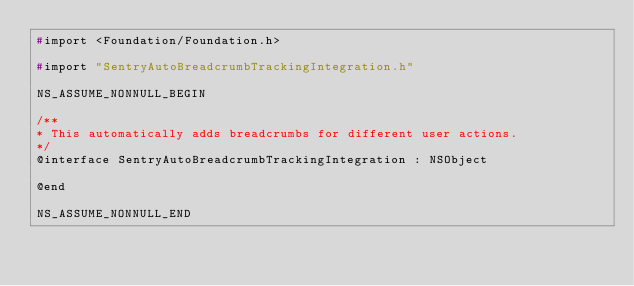<code> <loc_0><loc_0><loc_500><loc_500><_C_>#import <Foundation/Foundation.h>

#import "SentryAutoBreadcrumbTrackingIntegration.h"

NS_ASSUME_NONNULL_BEGIN

/**
* This automatically adds breadcrumbs for different user actions.
*/
@interface SentryAutoBreadcrumbTrackingIntegration : NSObject

@end

NS_ASSUME_NONNULL_END
</code> 